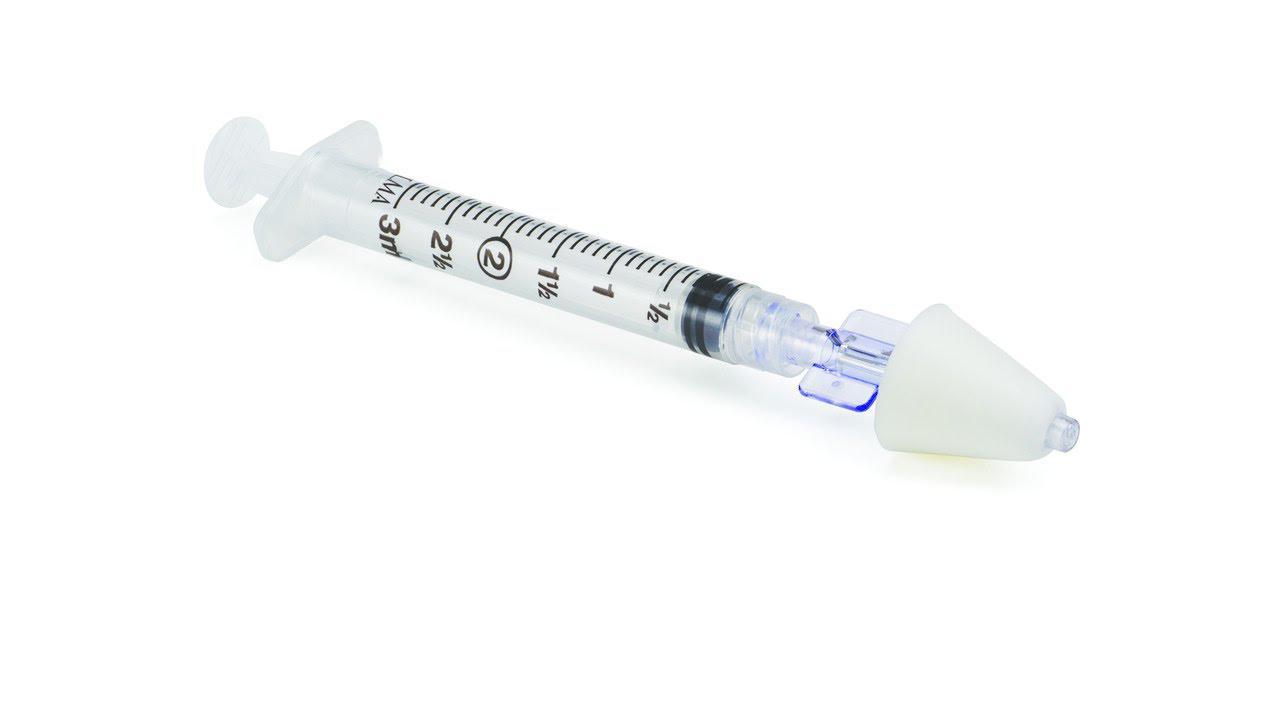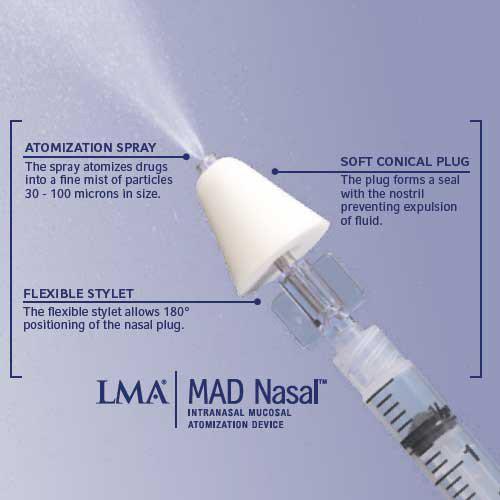The first image is the image on the left, the second image is the image on the right. Given the left and right images, does the statement "The image on the right contains a cone." hold true? Answer yes or no. Yes. 